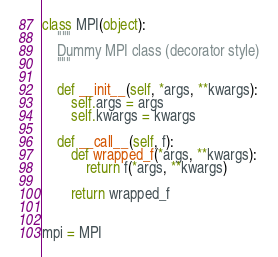<code> <loc_0><loc_0><loc_500><loc_500><_Python_>
class MPI(object):
    """
    Dummy MPI class (decorator style)
    """

    def __init__(self, *args, **kwargs):
        self.args = args
        self.kwargs = kwargs

    def __call__(self, f):
        def wrapped_f(*args, **kwargs):
            return f(*args, **kwargs)

        return wrapped_f


mpi = MPI
</code> 